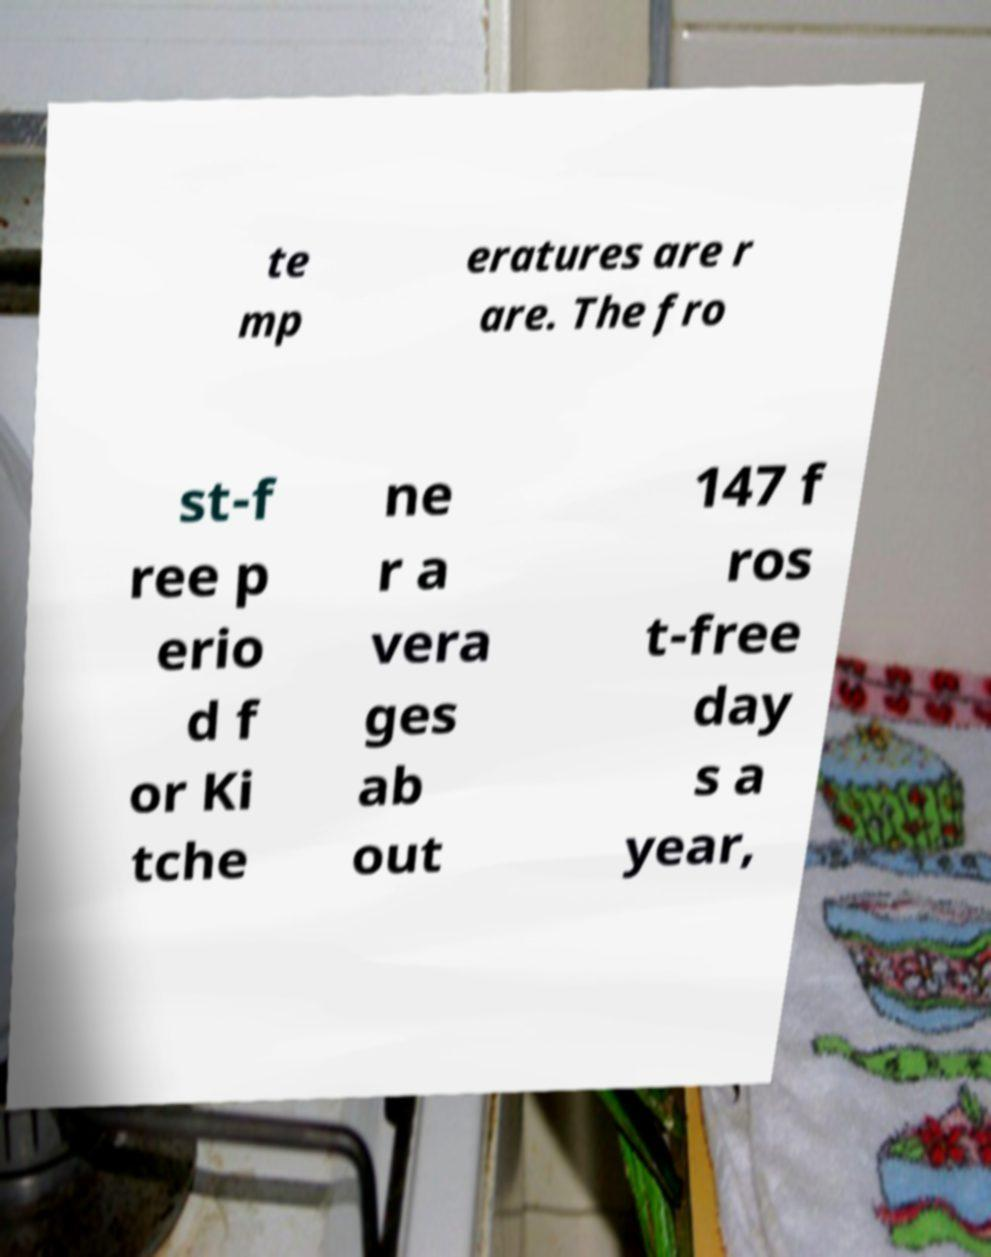What messages or text are displayed in this image? I need them in a readable, typed format. te mp eratures are r are. The fro st-f ree p erio d f or Ki tche ne r a vera ges ab out 147 f ros t-free day s a year, 